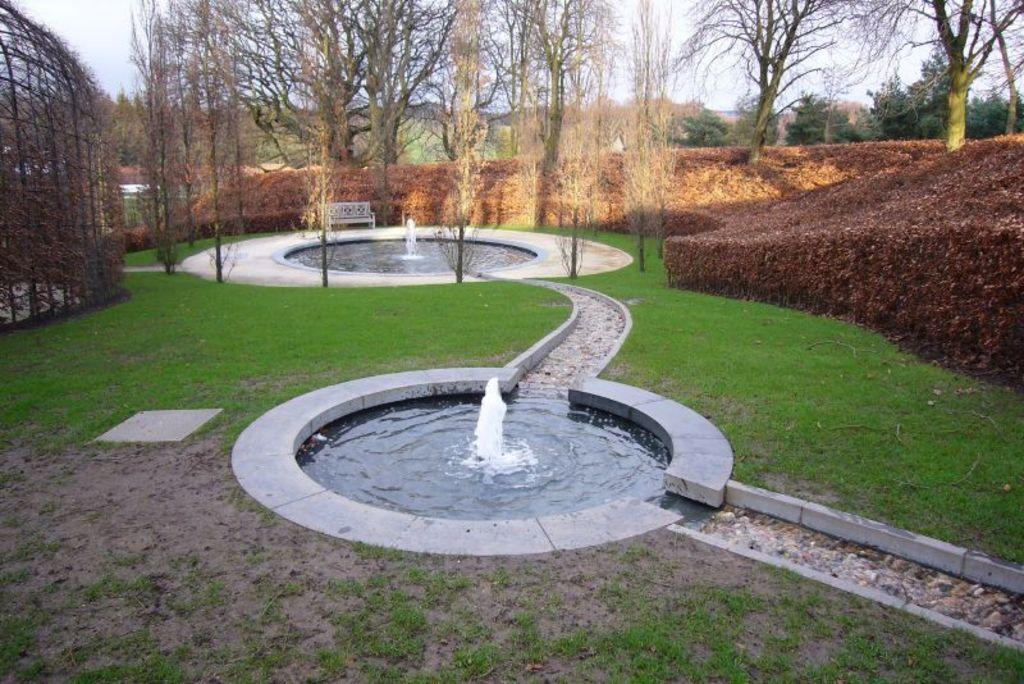Describe this image in one or two sentences. This picture consists of a fountain ,around the fountain I can see trees and , on the right side I can see bushes and trees ,on the left side I can see fence and,at the top I can see the sky. 